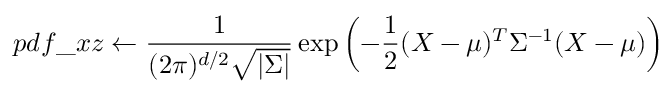<formula> <loc_0><loc_0><loc_500><loc_500>p d f \_ x z \leftarrow \frac { 1 } { ( 2 \pi ) ^ { d / 2 } \sqrt { | \Sigma | } } \exp \left ( - \frac { 1 } { 2 } ( X - \mu ) ^ { T } \Sigma ^ { - 1 } ( X - \mu ) \right )</formula> 